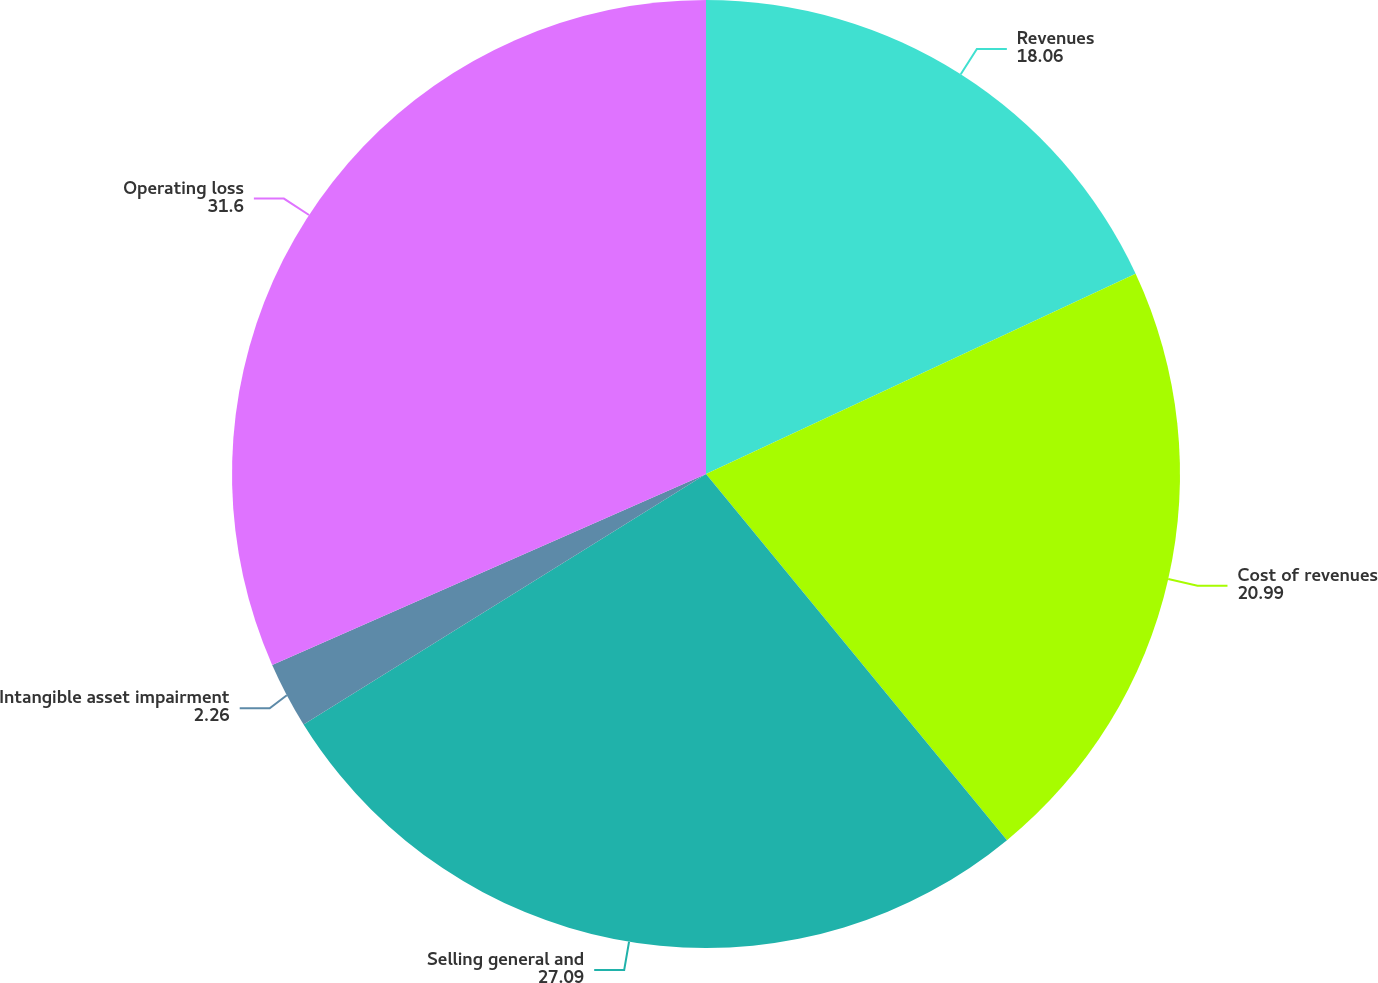<chart> <loc_0><loc_0><loc_500><loc_500><pie_chart><fcel>Revenues<fcel>Cost of revenues<fcel>Selling general and<fcel>Intangible asset impairment<fcel>Operating loss<nl><fcel>18.06%<fcel>20.99%<fcel>27.09%<fcel>2.26%<fcel>31.6%<nl></chart> 